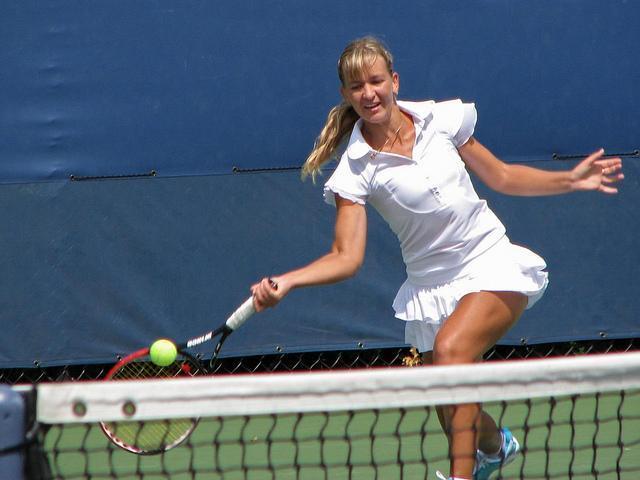How many people are there?
Give a very brief answer. 1. 